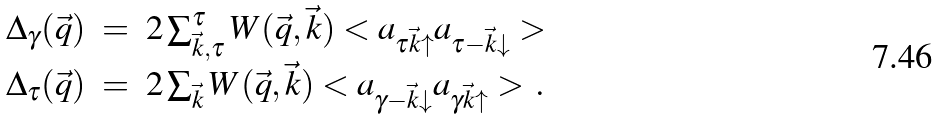<formula> <loc_0><loc_0><loc_500><loc_500>\begin{array} { c c l c l } \Delta _ { \gamma } ( \vec { q } ) & = & 2 \sum _ { \vec { k } , \tau } ^ { \tau } W ( \vec { q } , \vec { k } ) < a _ { \tau \vec { k } \uparrow } a _ { \tau - \vec { k } \downarrow } > \\ \Delta _ { \tau } ( \vec { q } ) & = & 2 \sum _ { \vec { k } } W ( \vec { q } , \vec { k } ) < a _ { \gamma - \vec { k } \downarrow } a _ { \gamma \vec { k } \uparrow } > \, . \end{array}</formula> 